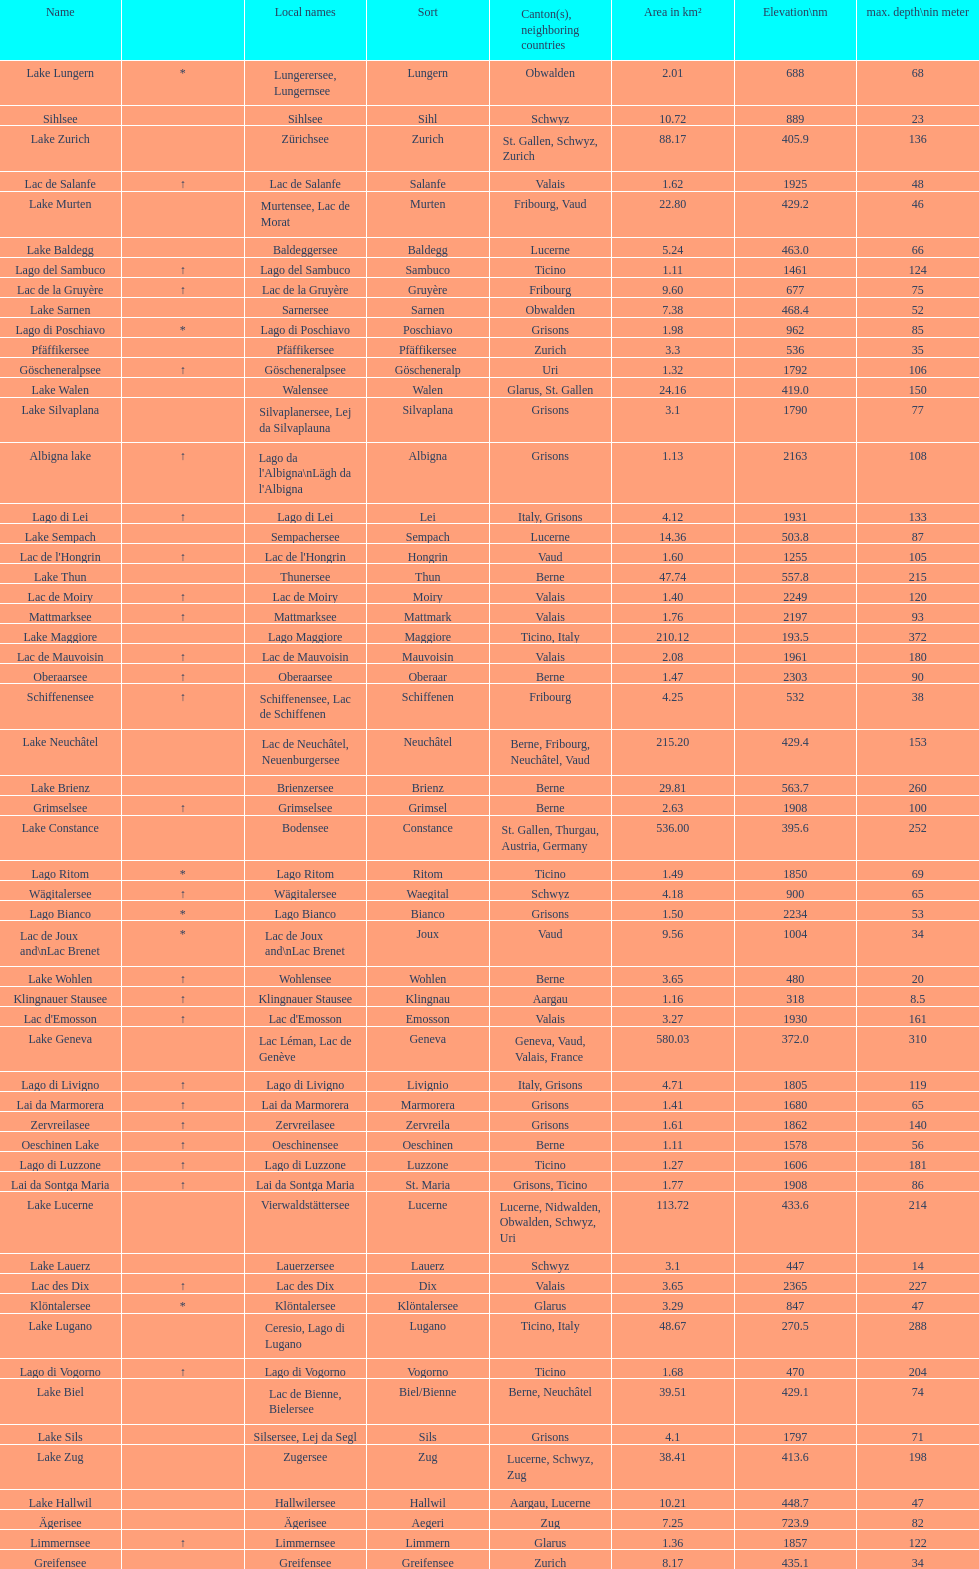What is the total area in km² of lake sils? 4.1. 